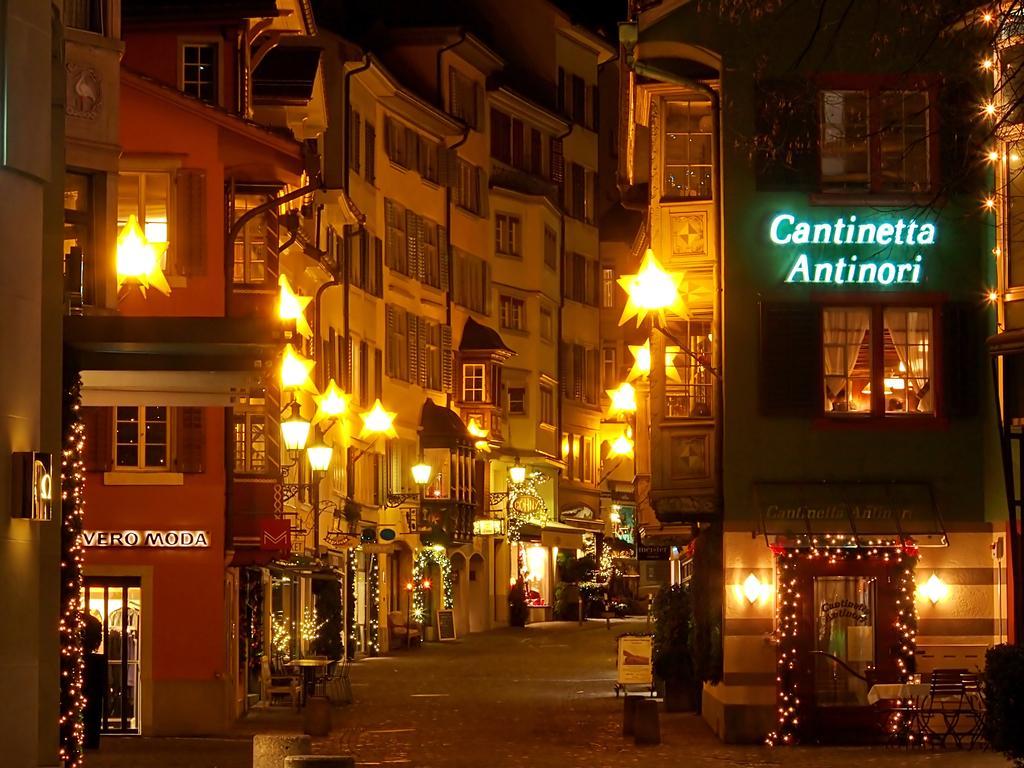Please provide a concise description of this image. There a pavement in the foreground area of the image, there are buildings, stars and decorated lights in the background. 